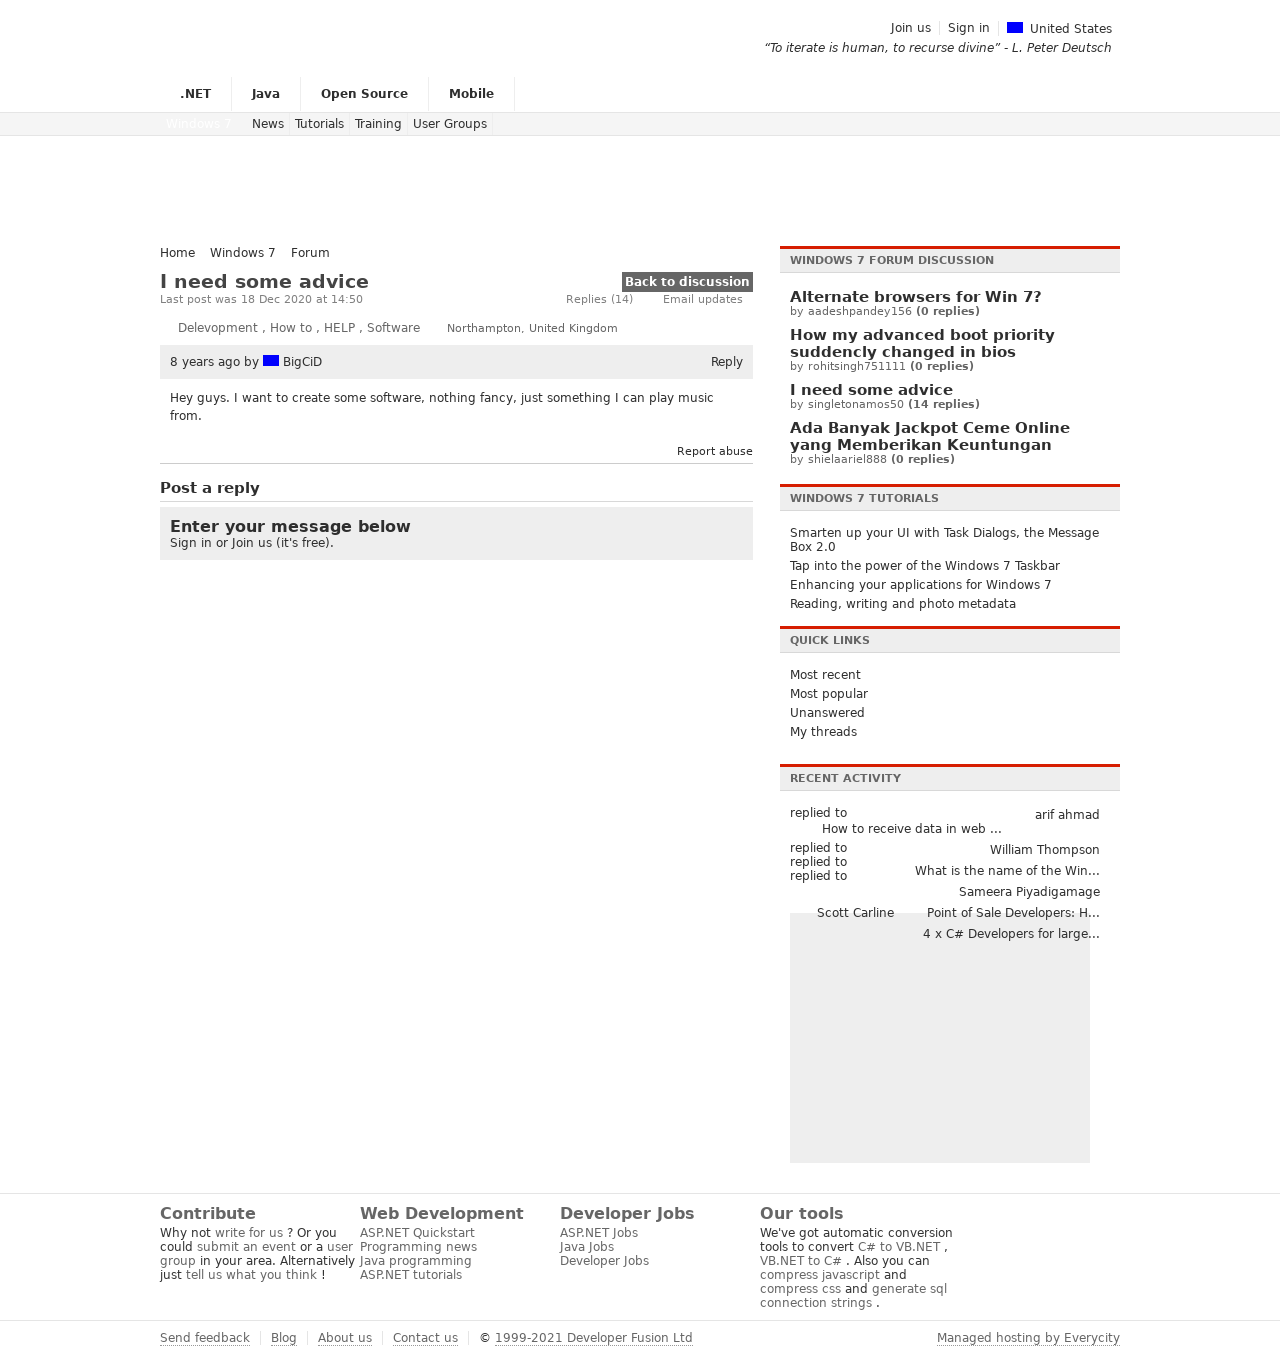What's the procedure for constructing this website from scratch with HTML? Constructing a website from scratch with HTML involves several steps. First, you would need to define the structure of your site with HTML tags, starting with <!DOCTYPE html> to define the document type. Following that, use <html> to wrap the entire content, <head> to contain meta information and links to stylesheets or scripts, and <body> to contain the visible page content. Within the body, you'd use various tags like <header>, <nav>, <section>, <article>, <footer>, and more to structure the content semantically. Remember to test your website in different browsers for compatibility. 